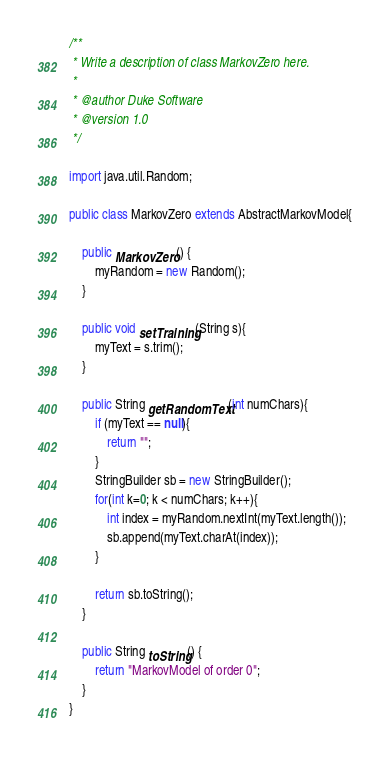Convert code to text. <code><loc_0><loc_0><loc_500><loc_500><_Java_>
/**
 * Write a description of class MarkovZero here.
 * 
 * @author Duke Software
 * @version 1.0
 */

import java.util.Random;

public class MarkovZero extends AbstractMarkovModel{

    public MarkovZero() {
        myRandom = new Random();
    }
    
    public void setTraining(String s){
        myText = s.trim();
    }
    
    public String getRandomText(int numChars){
        if (myText == null){
            return "";
        }
        StringBuilder sb = new StringBuilder();
        for(int k=0; k < numChars; k++){
            int index = myRandom.nextInt(myText.length());
            sb.append(myText.charAt(index));
        }
        
        return sb.toString();
    }
    
    public String toString() {
        return "MarkovModel of order 0";
    }
}
</code> 